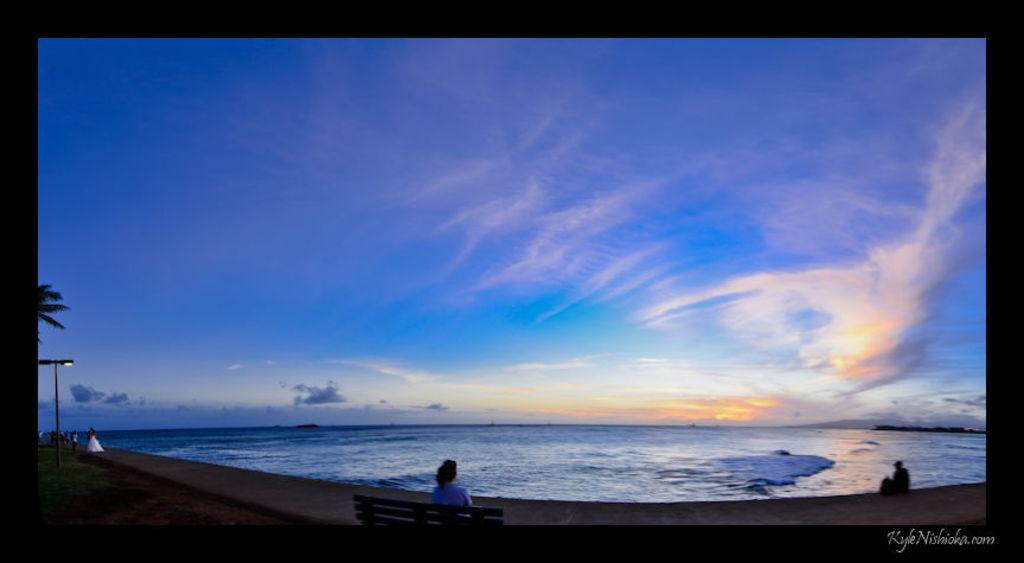<image>
Summarize the visual content of the image. On KyleNishioka.com, a woman sits at the shore on a bench and looks out to the ocean and the beautiful blue sky. 